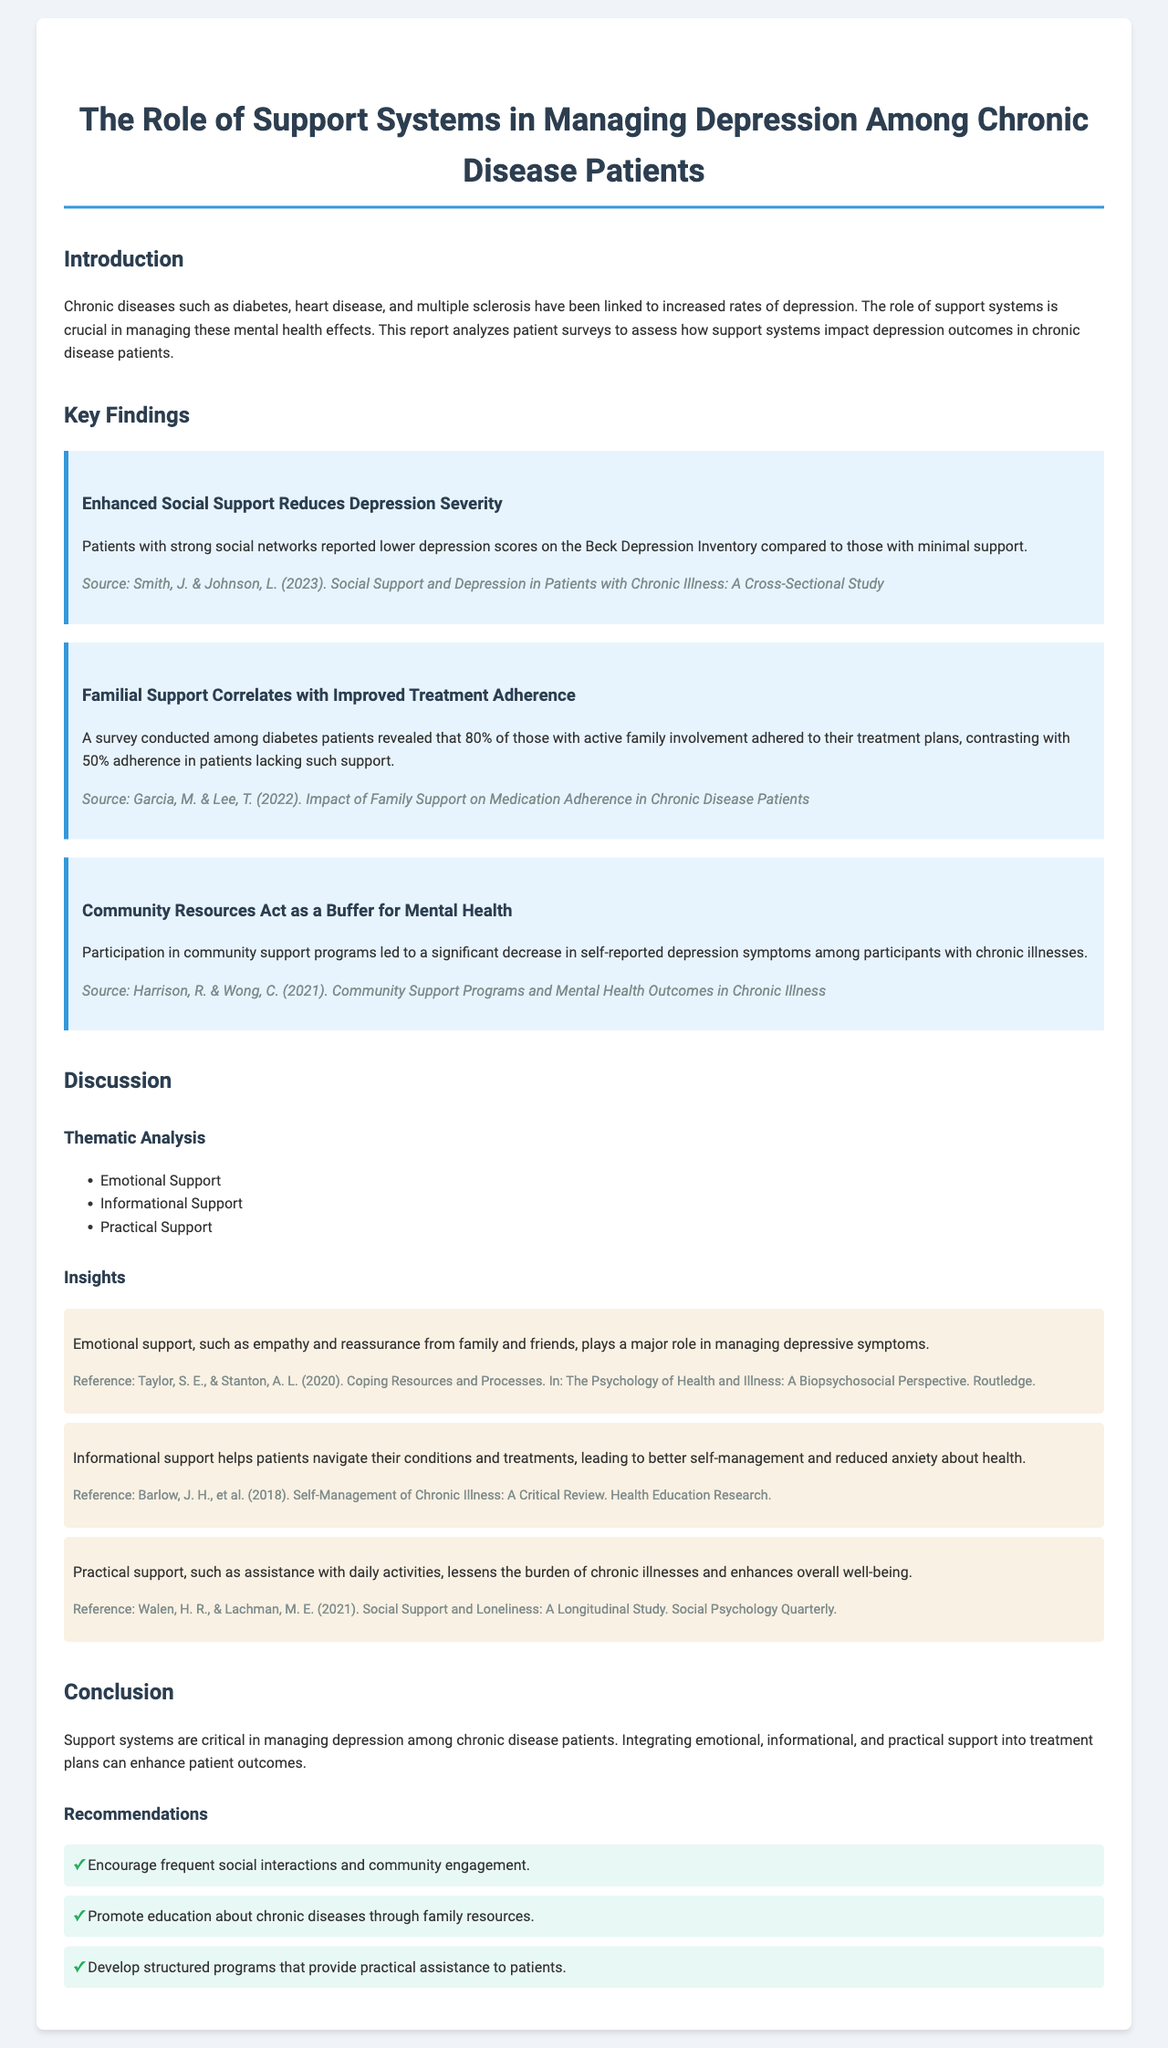what is the main focus of the report? The report analyzes the impact of support systems on depression outcomes in chronic disease patients.
Answer: impact of support systems on depression outcomes in chronic disease patients who conducted the study on social support and depression? This information is provided in the source of the key findings related to social support.
Answer: Smith, J. & Johnson, L what percentage of diabetes patients with family involvement adhere to treatment? The report specifies this percentage in the finding regarding familial support.
Answer: 80% which support type is considered essential for managing depressive symptoms? This supports the conclusion that emotional support is crucial for managing depression, mentioned in the insights.
Answer: emotional support what three types of support are identified in the thematic analysis? These support types are outlined specifically in the thematic analysis section of the document.
Answer: Emotional Support, Informational Support, Practical Support what is the total adherence percentage for patients lacking family support? The document provides this figure in the findings discussing family support correlating with adherence.
Answer: 50% how does community support participation affect depression? The report states the effect of community support on depression symptoms.
Answer: significant decrease in self-reported depression symptoms list one recommendation made in the report. Recommendations are outlined at the end of the report, indicating needed actions.
Answer: Encourage frequent social interactions and community engagement 